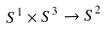Convert formula to latex. <formula><loc_0><loc_0><loc_500><loc_500>S ^ { 1 } \times S ^ { 3 } \rightarrow S ^ { 2 }</formula> 